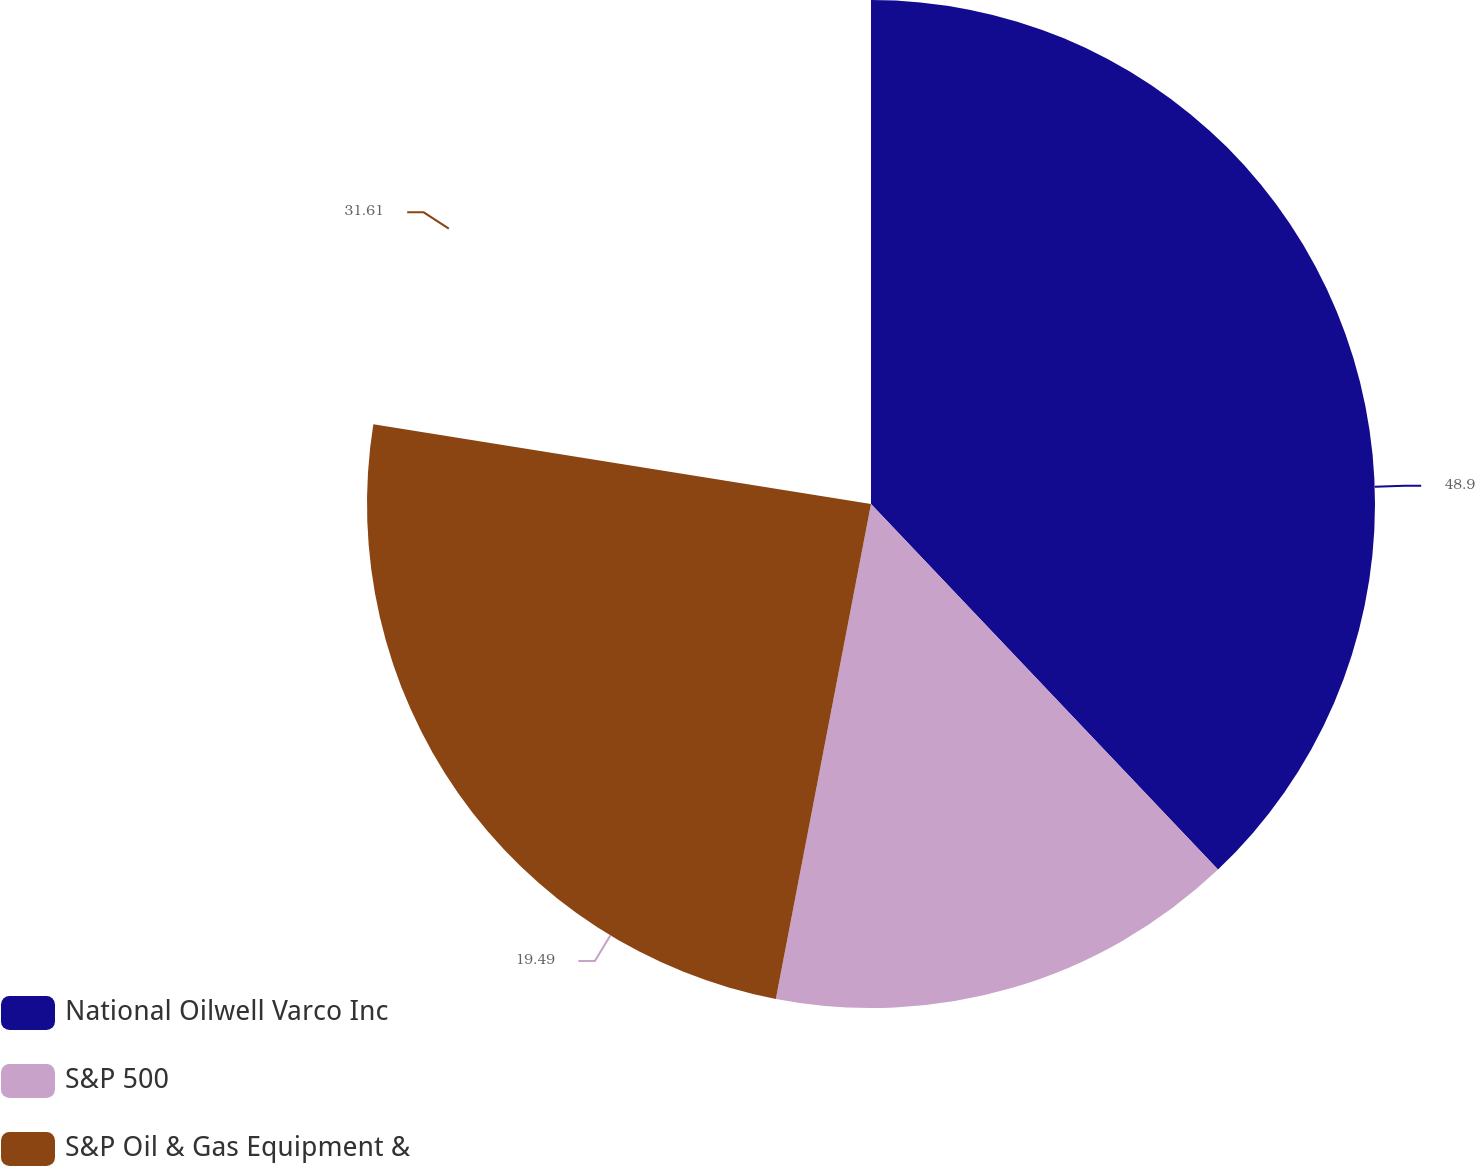<chart> <loc_0><loc_0><loc_500><loc_500><pie_chart><fcel>National Oilwell Varco Inc<fcel>S&P 500<fcel>S&P Oil & Gas Equipment &<nl><fcel>48.91%<fcel>19.49%<fcel>31.61%<nl></chart> 